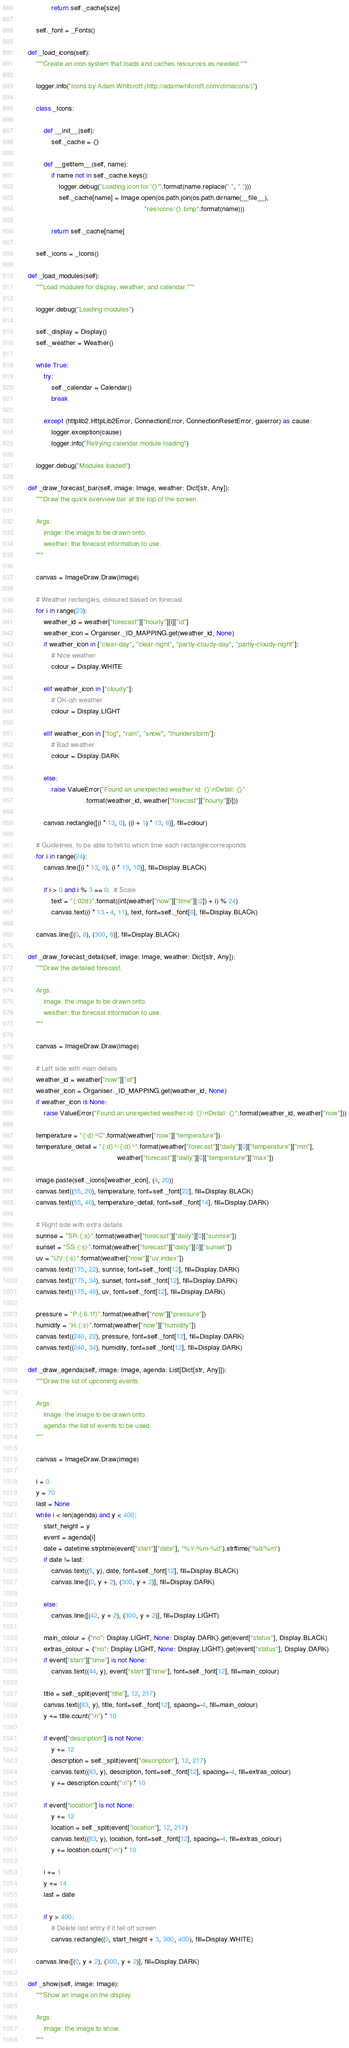Convert code to text. <code><loc_0><loc_0><loc_500><loc_500><_Python_>
                return self._cache[size]

        self._font = _Fonts()

    def _load_icons(self):
        """Create an icon system that loads and caches resources as needed."""

        logger.info("Icons by Adam Whitcroft (http://adamwhitcroft.com/climacons/)")

        class _Icons:

            def __init__(self):
                self._cache = {}

            def __getitem__(self, name):
                if name not in self._cache.keys():
                    logger.debug("Loading icon for '{}'".format(name.replace("-", " ")))
                    self._cache[name] = Image.open(os.path.join(os.path.dirname(__file__),
                                                                "res/icons/{}.bmp".format(name)))

                return self._cache[name]

        self._icons = _Icons()

    def _load_modules(self):
        """Load modules for display, weather, and calendar."""

        logger.debug("Loading modules")

        self._display = Display()
        self._weather = Weather()

        while True:
            try:
                self._calendar = Calendar()
                break

            except (httplib2.HttpLib2Error, ConnectionError, ConnectionResetError, gaierror) as cause:
                logger.exception(cause)
                logger.info("Retrying calendar module loading")

        logger.debug("Modules loaded")

    def _draw_forecast_bar(self, image: Image, weather: Dict[str, Any]):
        """Draw the quick overview bar at the top of the screen.

        Args:
            image: the image to be drawn onto.
            weather: the forecast information to use.
        """

        canvas = ImageDraw.Draw(image)

        # Weather rectangles, coloured based on forecast
        for i in range(23):
            weather_id = weather["forecast"]["hourly"][i]["id"]
            weather_icon = Organiser._ID_MAPPING.get(weather_id, None)
            if weather_icon in ["clear-day", "clear-night", "partly-cloudy-day", "partly-cloudy-night"]:
                # Nice weather
                colour = Display.WHITE

            elif weather_icon in ["cloudy"]:
                # OK-ish weather
                colour = Display.LIGHT

            elif weather_icon in ["fog", "rain", "snow", "thunderstorm"]:
                # Bad weather
                colour = Display.DARK

            else:
                raise ValueError("Found an unexpected weather id: {}\nDetail: {}"
                                 .format(weather_id, weather["forecast"]["hourly"][i]))

            canvas.rectangle([(i * 13, 0), ((i + 1) * 13, 8)], fill=colour)

        # Guidelines, to be able to tell to which time each rectangle corresponds
        for i in range(24):
            canvas.line([(i * 13, 8), (i * 13, 10)], fill=Display.BLACK)

            if i > 0 and i % 3 == 0:  # Scale
                text = "{:02d}".format((int(weather["now"]["time"][:2]) + i) % 24)
                canvas.text((i * 13 - 4, 11), text, font=self._font[8], fill=Display.BLACK)

        canvas.line([(0, 8), (300, 8)], fill=Display.BLACK)

    def _draw_forecast_detail(self, image: Image, weather: Dict[str, Any]):
        """Draw the detailed forecast.

        Args:
            image: the image to be drawn onto.
            weather: the forecast information to use.
        """

        canvas = ImageDraw.Draw(image)

        # Left side with main details
        weather_id = weather["now"]["id"]
        weather_icon = Organiser._ID_MAPPING.get(weather_id, None)
        if weather_icon is None:
            raise ValueError("Found an unexpected weather id: {}\nDetail: {}".format(weather_id, weather["now"]))

        temperature = "{:d}°C".format(weather["now"]["temperature"])
        temperature_detail = "{:d}°/{:d}°".format(weather["forecast"]["daily"][0]["temperature"]["min"],
                                                  weather["forecast"]["daily"][0]["temperature"]["max"])

        image.paste(self._icons[weather_icon], (4, 20))
        canvas.text((55, 20), temperature, font=self._font[22], fill=Display.BLACK)
        canvas.text((55, 46), temperature_detail, font=self._font[14], fill=Display.DARK)

        # Right side with extra details
        sunrise = "SR:{:s}".format(weather["forecast"]["daily"][0]["sunrise"])
        sunset = "SS:{:s}".format(weather["forecast"]["daily"][0]["sunset"])
        uv = "UV:{:s}".format(weather["now"]["uv index"])
        canvas.text((175, 22), sunrise, font=self._font[12], fill=Display.DARK)
        canvas.text((175, 34), sunset, font=self._font[12], fill=Display.DARK)
        canvas.text((175, 46), uv, font=self._font[12], fill=Display.DARK)

        pressure = "P:{:6.1f}".format(weather["now"]["pressure"])
        humidity = "H:{:s}".format(weather["now"]["humidity"])
        canvas.text((240, 22), pressure, font=self._font[12], fill=Display.DARK)
        canvas.text((240, 34), humidity, font=self._font[12], fill=Display.DARK)

    def _draw_agenda(self, image: Image, agenda: List[Dict[str, Any]]):
        """Draw the list of upcoming events.

        Args:
            image: the image to be drawn onto.
            agenda: the list of events to be used.
        """

        canvas = ImageDraw.Draw(image)

        i = 0
        y = 70
        last = None
        while i < len(agenda) and y < 400:
            start_height = y
            event = agenda[i]
            date = datetime.strptime(event["start"]["date"], "%Y-%m-%d").strftime("%d/%m")
            if date != last:
                canvas.text((5, y), date, font=self._font[12], fill=Display.BLACK)
                canvas.line([(0, y + 2), (300, y + 2)], fill=Display.DARK)

            else:
                canvas.line([(42, y + 2), (300, y + 2)], fill=Display.LIGHT)

            main_colour = {"no": Display.LIGHT, None: Display.DARK}.get(event["status"], Display.BLACK)
            extras_colour = {"no": Display.LIGHT, None: Display.LIGHT}.get(event["status"], Display.DARK)
            if event["start"]["time"] is not None:
                canvas.text((44, y), event["start"]["time"], font=self._font[12], fill=main_colour)

            title = self._split(event["title"], 12, 217)
            canvas.text((83, y), title, font=self._font[12], spacing=-4, fill=main_colour)
            y += title.count("\n") * 10

            if event["description"] is not None:
                y += 12
                description = self._split(event["description"], 12, 217)
                canvas.text((83, y), description, font=self._font[12], spacing=-4, fill=extras_colour)
                y += description.count("\n") * 10

            if event["location"] is not None:
                y += 12
                location = self._split(event["location"], 12, 217)
                canvas.text((83, y), location, font=self._font[12], spacing=-4, fill=extras_colour)
                y += location.count("\n") * 10

            i += 1
            y += 14
            last = date

            if y > 400:
                # Delete last entry if it fell off screen
                canvas.rectangle((0, start_height + 3, 300, 400), fill=Display.WHITE)

        canvas.line([(0, y + 2), (300, y + 2)], fill=Display.DARK)

    def _show(self, image: Image):
        """Show an image on the display.

        Args:
            image: the image to show.
        """
</code> 